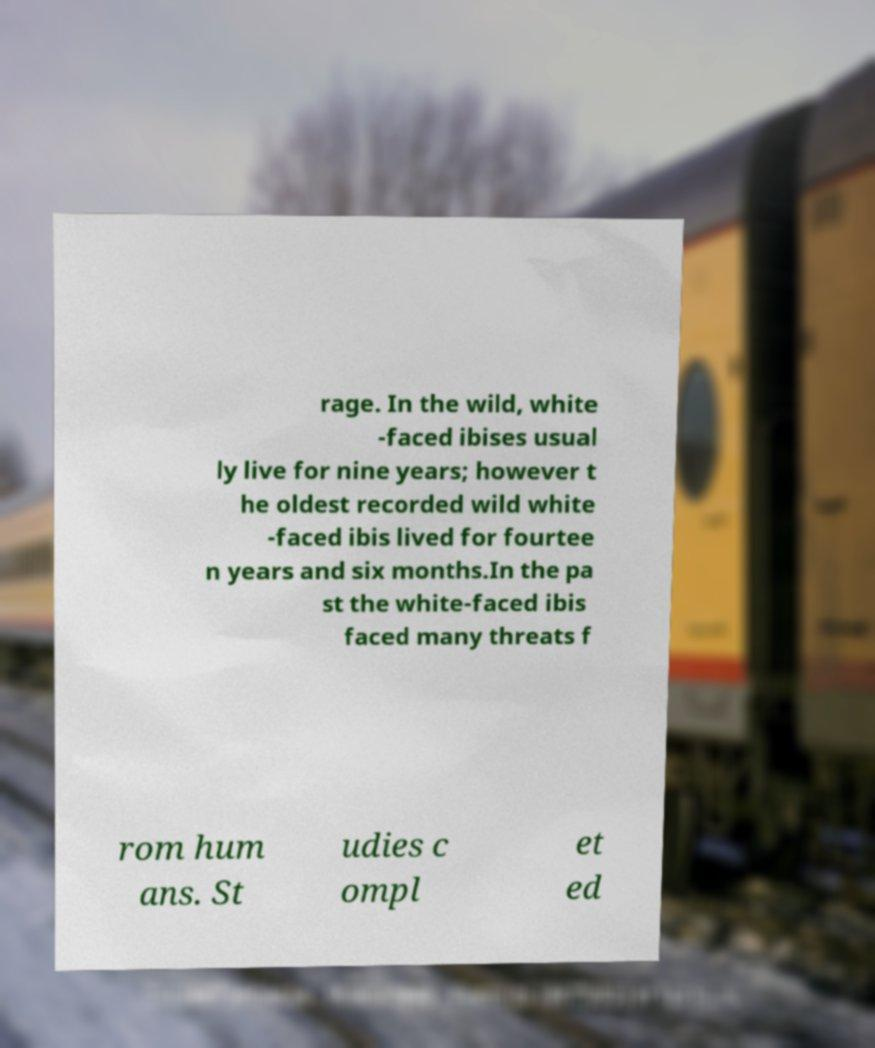Can you accurately transcribe the text from the provided image for me? rage. In the wild, white -faced ibises usual ly live for nine years; however t he oldest recorded wild white -faced ibis lived for fourtee n years and six months.In the pa st the white-faced ibis faced many threats f rom hum ans. St udies c ompl et ed 